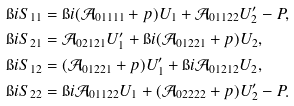Convert formula to latex. <formula><loc_0><loc_0><loc_500><loc_500>& \i i S _ { 1 1 } = \i i ( \mathcal { A } _ { 0 1 1 1 1 } + p ) U _ { 1 } + \mathcal { A } _ { 0 1 1 2 2 } U ^ { \prime } _ { 2 } - P , \\ & \i i S _ { 2 1 } = \mathcal { A } _ { 0 2 1 2 1 } U ^ { \prime } _ { 1 } + \i i ( \mathcal { A } _ { 0 1 2 2 1 } + p ) U _ { 2 } , \\ & \i i S _ { 1 2 } = ( \mathcal { A } _ { 0 1 2 2 1 } + p ) U ^ { \prime } _ { 1 } + \i i \mathcal { A } _ { 0 1 2 1 2 } U _ { 2 } , \\ & \i i S _ { 2 2 } = \i i \mathcal { A } _ { 0 1 1 2 2 } U _ { 1 } + ( \mathcal { A } _ { 0 2 2 2 2 } + p ) U ^ { \prime } _ { 2 } - P .</formula> 